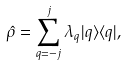<formula> <loc_0><loc_0><loc_500><loc_500>\hat { \rho } = \sum _ { q = - j } ^ { j } \lambda _ { q } | q \rangle \langle q | ,</formula> 